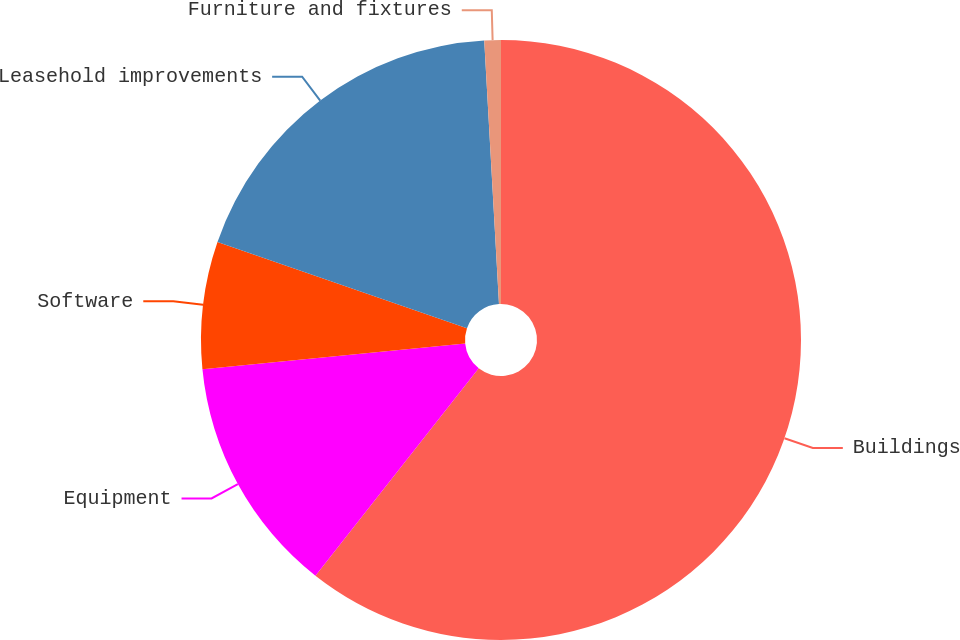<chart> <loc_0><loc_0><loc_500><loc_500><pie_chart><fcel>Buildings<fcel>Equipment<fcel>Software<fcel>Leasehold improvements<fcel>Furniture and fixtures<nl><fcel>60.62%<fcel>12.83%<fcel>6.86%<fcel>18.81%<fcel>0.89%<nl></chart> 